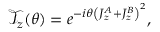<formula> <loc_0><loc_0><loc_500><loc_500>\begin{array} { r } { \mathcal { T } _ { z } ( \theta ) = e ^ { - i \theta \left ( J _ { z } ^ { A } + J _ { z } ^ { B } \right ) ^ { 2 } } , } \end{array}</formula> 